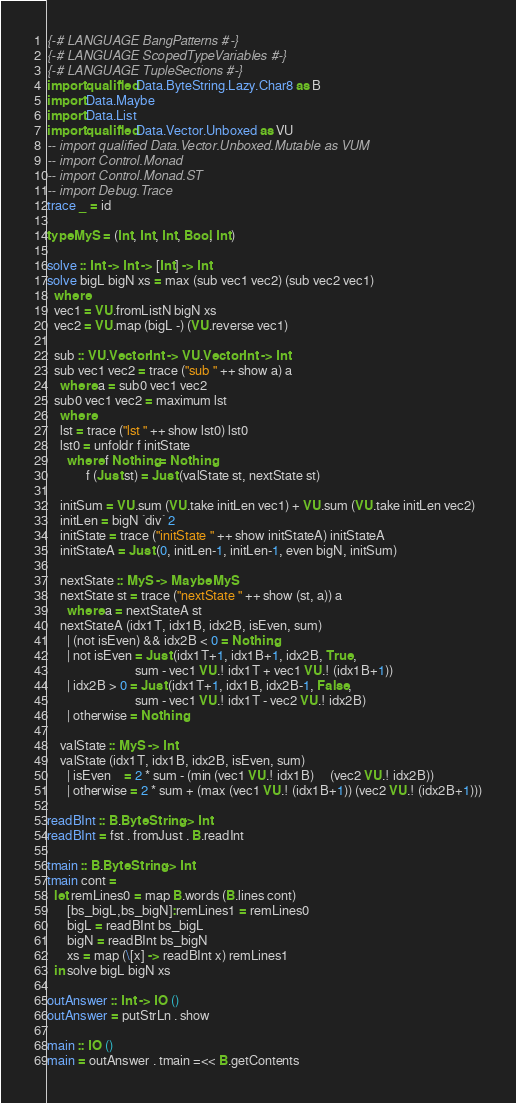<code> <loc_0><loc_0><loc_500><loc_500><_Haskell_>{-# LANGUAGE BangPatterns #-}
{-# LANGUAGE ScopedTypeVariables #-}
{-# LANGUAGE TupleSections #-}
import qualified Data.ByteString.Lazy.Char8 as B
import Data.Maybe
import Data.List
import qualified Data.Vector.Unboxed as VU
-- import qualified Data.Vector.Unboxed.Mutable as VUM
-- import Control.Monad
-- import Control.Monad.ST
-- import Debug.Trace
trace _ = id

type MyS = (Int, Int, Int, Bool, Int)

solve :: Int -> Int -> [Int] -> Int
solve bigL bigN xs = max (sub vec1 vec2) (sub vec2 vec1)
  where
  vec1 = VU.fromListN bigN xs
  vec2 = VU.map (bigL -) (VU.reverse vec1)

  sub :: VU.Vector Int -> VU.Vector Int -> Int
  sub vec1 vec2 = trace ("sub " ++ show a) a
    where a = sub0 vec1 vec2
  sub0 vec1 vec2 = maximum lst
    where
    lst = trace ("lst " ++ show lst0) lst0
    lst0 = unfoldr f initState
      where f Nothing = Nothing
            f (Just st) = Just (valState st, nextState st)

    initSum = VU.sum (VU.take initLen vec1) + VU.sum (VU.take initLen vec2)
    initLen = bigN `div` 2
    initState = trace ("initState " ++ show initStateA) initStateA
    initStateA = Just (0, initLen-1, initLen-1, even bigN, initSum)
  
    nextState :: MyS -> Maybe MyS
    nextState st = trace ("nextState " ++ show (st, a)) a
      where a = nextStateA st
    nextStateA (idx1T, idx1B, idx2B, isEven, sum)
      | (not isEven) && idx2B < 0 = Nothing
      | not isEven = Just (idx1T+1, idx1B+1, idx2B, True,
                           sum - vec1 VU.! idx1T + vec1 VU.! (idx1B+1))
      | idx2B > 0 = Just (idx1T+1, idx1B, idx2B-1, False,
                           sum - vec1 VU.! idx1T - vec2 VU.! idx2B)
      | otherwise = Nothing
  
    valState :: MyS -> Int
    valState (idx1T, idx1B, idx2B, isEven, sum)
      | isEven    = 2 * sum - (min (vec1 VU.! idx1B)     (vec2 VU.! idx2B))
      | otherwise = 2 * sum + (max (vec1 VU.! (idx1B+1)) (vec2 VU.! (idx2B+1)))

readBInt :: B.ByteString -> Int
readBInt = fst . fromJust . B.readInt

tmain :: B.ByteString -> Int
tmain cont =
  let remLines0 = map B.words (B.lines cont)
      [bs_bigL,bs_bigN]:remLines1 = remLines0
      bigL = readBInt bs_bigL
      bigN = readBInt bs_bigN
      xs = map (\[x] -> readBInt x) remLines1
  in solve bigL bigN xs

outAnswer :: Int -> IO ()
outAnswer = putStrLn . show

main :: IO ()
main = outAnswer . tmain =<< B.getContents
</code> 